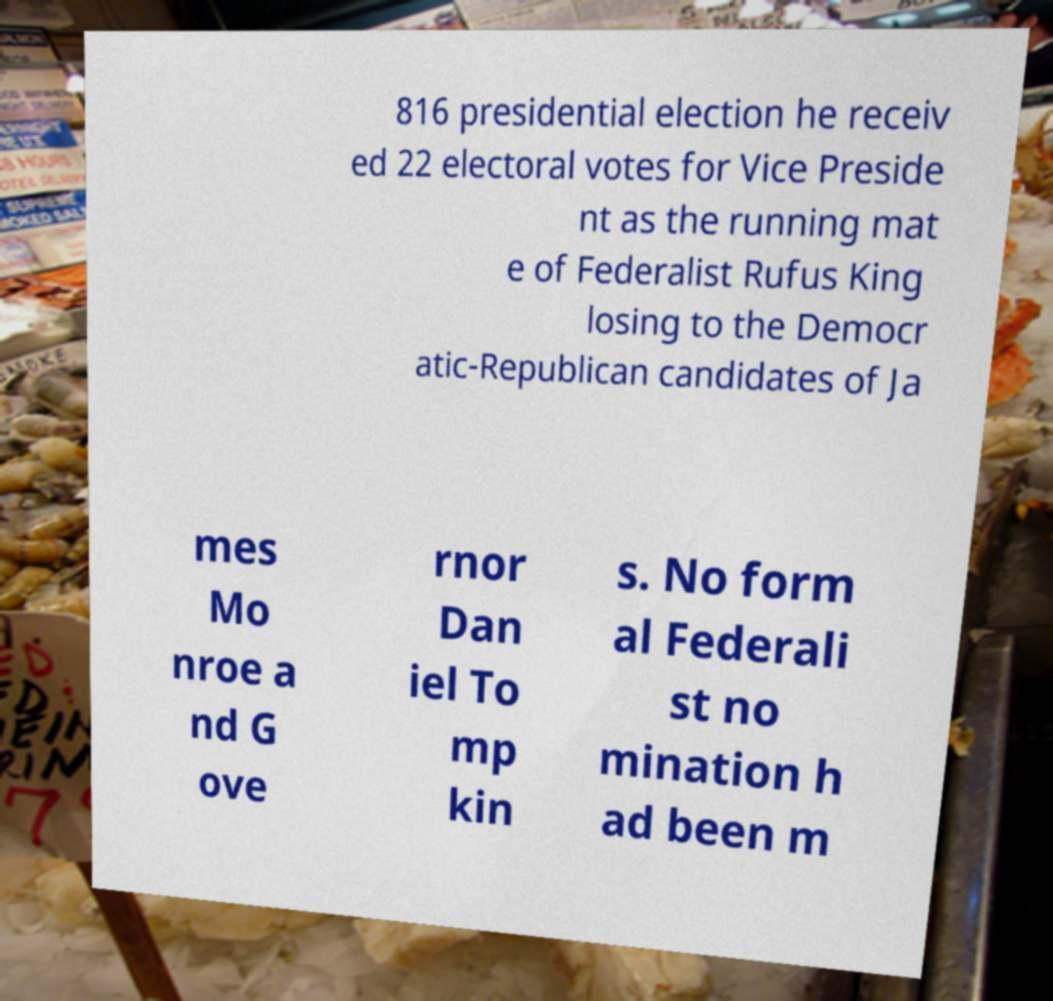Please read and relay the text visible in this image. What does it say? 816 presidential election he receiv ed 22 electoral votes for Vice Preside nt as the running mat e of Federalist Rufus King losing to the Democr atic-Republican candidates of Ja mes Mo nroe a nd G ove rnor Dan iel To mp kin s. No form al Federali st no mination h ad been m 